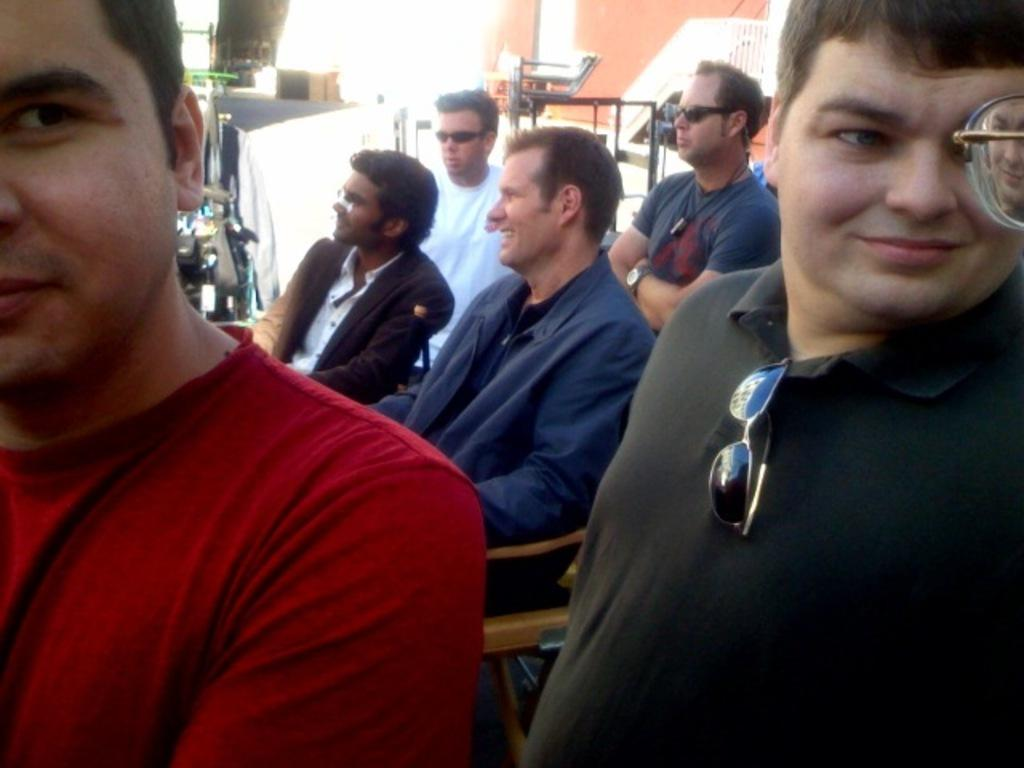How many people are in the image? There is a group of people in the image. What are the people wearing? The people are wearing different color dresses. Can you describe any specific accessory one person is wearing? One person is wearing goggles. What can be seen in the background of the image? There are objects, railing, and a wall in the background of the image. What type of pain is the person with goggles experiencing in the image? There is no indication of pain in the image; the person with goggles is not shown to be experiencing any discomfort. 